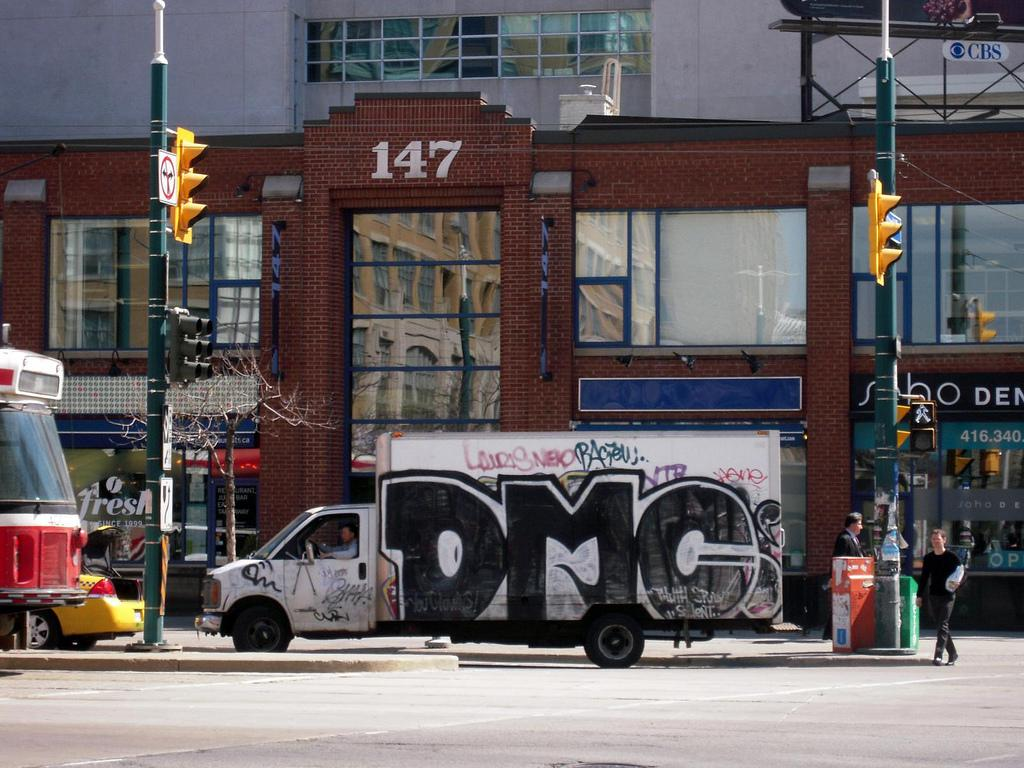Question: how many cars are there in the picture?
Choices:
A. 1.
B. 2.
C. 3.
D. 4.
Answer with the letter. Answer: C Question: how is the weather like?
Choices:
A. Hot.
B. Cloudy.
C. Rainy.
D. Sunny.
Answer with the letter. Answer: D Question: when in a day is this taken?
Choices:
A. Early morning.
B. Daytime.
C. Nighttime.
D. Afternoon.
Answer with the letter. Answer: B Question: what is the color of the truck in the middle?
Choices:
A. Red.
B. Brown.
C. White.
D. Silver.
Answer with the letter. Answer: C Question: what is the gender of people in the picture?
Choices:
A. Female.
B. Male and female.
C. Male.
D. Androgynous.
Answer with the letter. Answer: C Question: where was the photo taken?
Choices:
A. A sidewalk.
B. On the street.
C. Next to a building.
D. In a car.
Answer with the letter. Answer: B Question: where was the photo taken?
Choices:
A. On the boardwalk.
B. On Crosswalk.
C. On Train Track.
D. On the street.
Answer with the letter. Answer: D Question: where was the photo taken?
Choices:
A. On a balcony.
B. At an airport.
C. Near the train station.
D. On the street.
Answer with the letter. Answer: D Question: how is the pedestrian holding the package?
Choices:
A. In his hand.
B. In his satchel.
C. On his head.
D. Between his legs.
Answer with the letter. Answer: A Question: what is in the reflection on some of the windows?
Choices:
A. A cat.
B. The TV screen is reflected.
C. People sitting around a table.
D. Other buildings.
Answer with the letter. Answer: D Question: what color are the traffic lights?
Choices:
A. Red.
B. Green.
C. Yellow.
D. Flashing red.
Answer with the letter. Answer: C Question: where is the truck parked?
Choices:
A. In the parking lot.
B. In the street.
C. In front of a red brick building.
D. In the parking garage.
Answer with the letter. Answer: C Question: what is the other vehicle parked on the curbside?
Choices:
A. A car.
B. A taxi.
C. A bus.
D. A bike.
Answer with the letter. Answer: B Question: what type of marking is on the truck?
Choices:
A. Graffiti.
B. Signage.
C. Advertisements.
D. Blue and red.
Answer with the letter. Answer: A Question: how are the traffic lights installed?
Choices:
A. In the ground.
B. Surrounded by concrete.
C. Near the road.
D. Affixed to poles.
Answer with the letter. Answer: D Question: what is the pedestrian wearing?
Choices:
A. A blue sling.
B. A white shirt.
C. A cast on his arm.
D. Blue jeans.
Answer with the letter. Answer: C Question: what does the box truck say?
Choices:
A. Shipping.
B. Dmc.
C. Ups.
D. FedEx.
Answer with the letter. Answer: B 